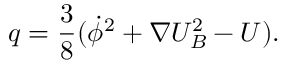<formula> <loc_0><loc_0><loc_500><loc_500>q = \frac { 3 } { 8 } ( \dot { \phi } ^ { 2 } + \nabla U _ { B } ^ { 2 } - U ) .</formula> 